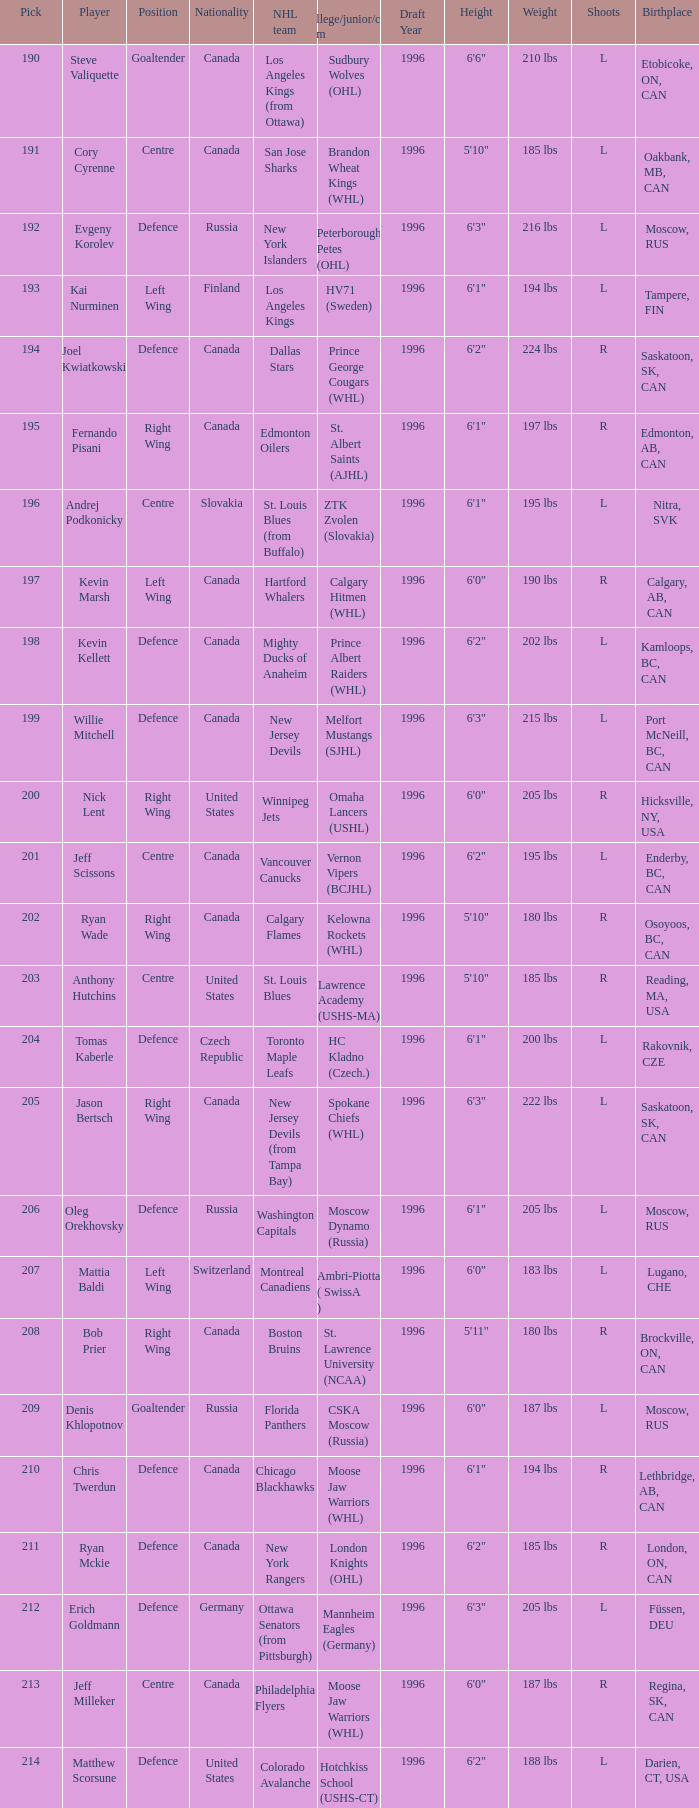Name the pick for matthew scorsune 214.0. 